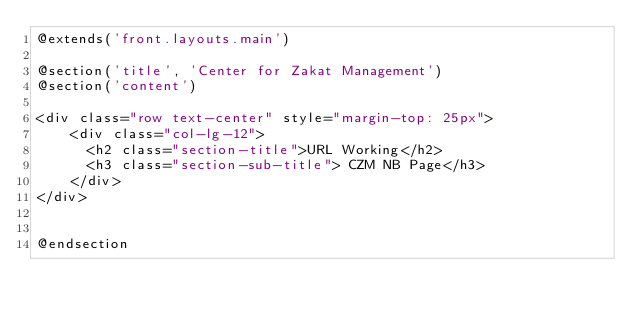<code> <loc_0><loc_0><loc_500><loc_500><_PHP_>@extends('front.layouts.main')

@section('title', 'Center for Zakat Management')
@section('content')

<div class="row text-center" style="margin-top: 25px">
    <div class="col-lg-12">
      <h2 class="section-title">URL Working</h2>
      <h3 class="section-sub-title"> CZM NB Page</h3>
    </div>
</div>


@endsection

</code> 